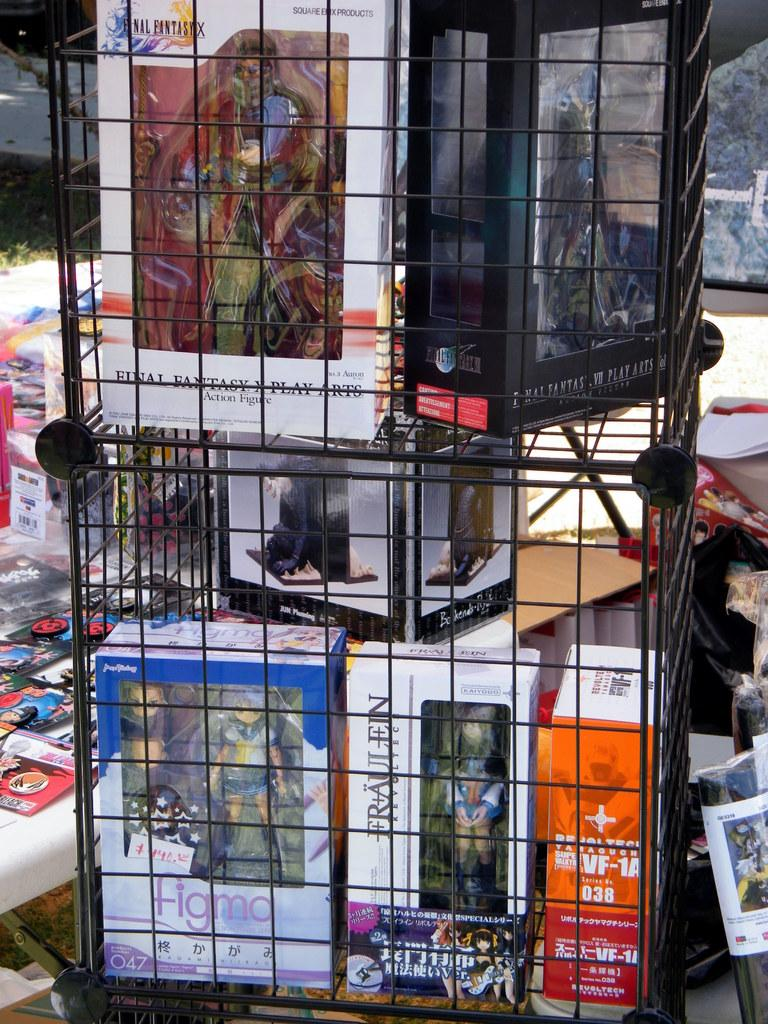What is inside the boxes that are visible in the image? The boxes contain dolls. How are the boxes arranged in the image? The boxes are arranged on shelves. What is the other piece of furniture present in the image? There is a table in the image. What can be found on the table in the image? There are objects on the table. What is the tax rate for the dolls in the image? There is no information about tax rates in the image, as it focuses on the arrangement of boxes and dolls. 